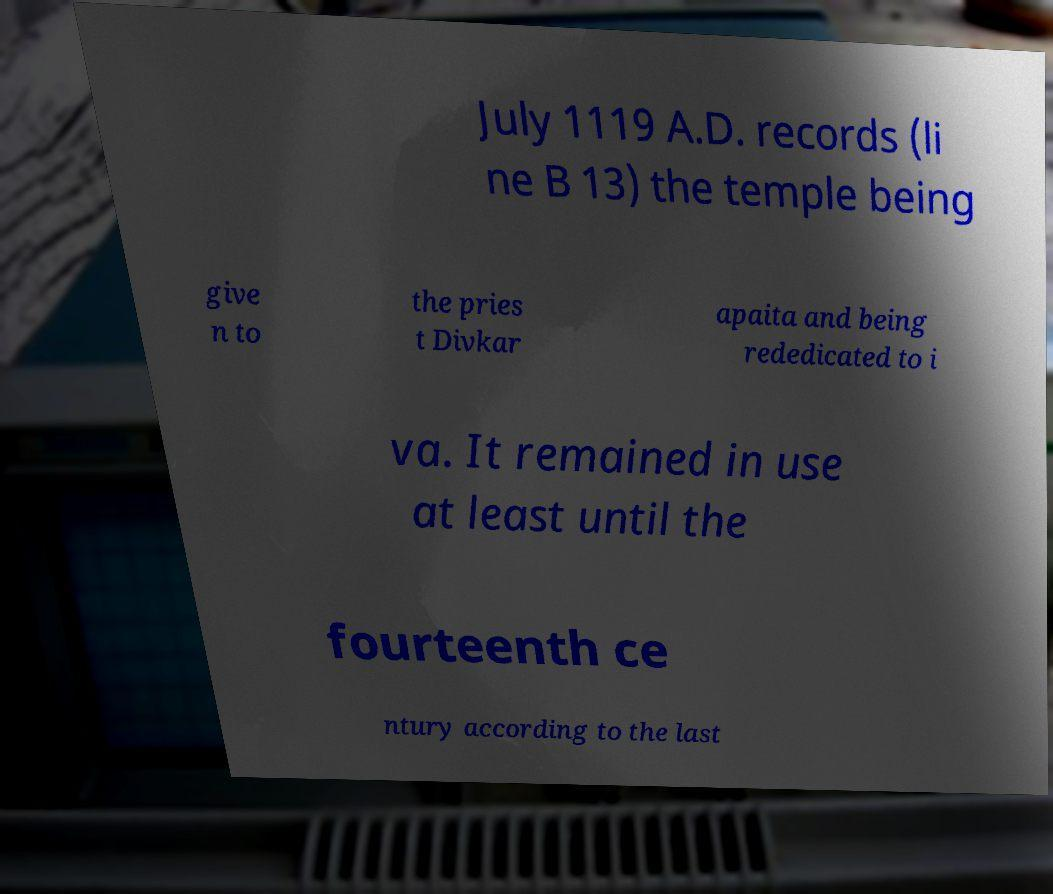I need the written content from this picture converted into text. Can you do that? July 1119 A.D. records (li ne B 13) the temple being give n to the pries t Divkar apaita and being rededicated to i va. It remained in use at least until the fourteenth ce ntury according to the last 